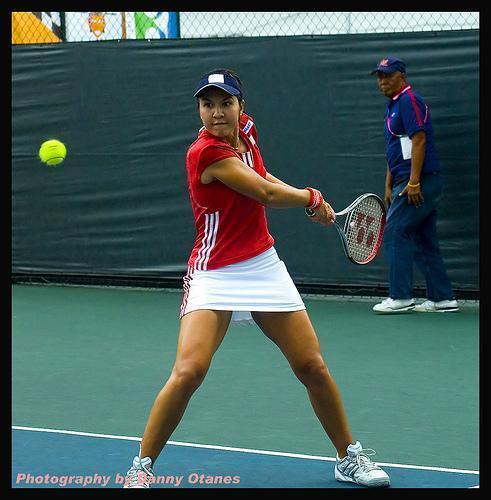How many white stripes are visible on the side of the red shirt closest to the viewer?
Give a very brief answer. 3. How many people can be seen?
Give a very brief answer. 2. 